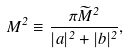<formula> <loc_0><loc_0><loc_500><loc_500>M ^ { 2 } \equiv \frac { \pi { \widetilde { M } } ^ { 2 } } { | a | ^ { 2 } + | b | ^ { 2 } } ,</formula> 